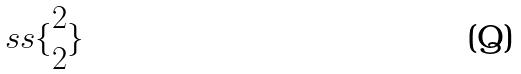Convert formula to latex. <formula><loc_0><loc_0><loc_500><loc_500>s s \{ \begin{matrix} 2 \\ 2 \end{matrix} \}</formula> 